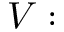<formula> <loc_0><loc_0><loc_500><loc_500>V \colon</formula> 